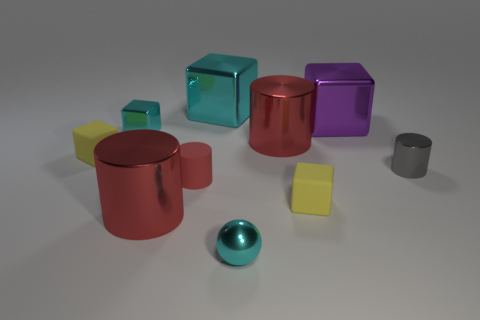What number of other things are there of the same color as the small sphere?
Give a very brief answer. 2. Do the metal sphere and the tiny shiny cylinder have the same color?
Your response must be concise. No. There is a yellow matte block to the left of the large metallic cylinder to the left of the small cyan shiny sphere; what size is it?
Your response must be concise. Small. Are the small cyan thing on the left side of the small red matte cylinder and the tiny yellow object that is on the right side of the tiny cyan block made of the same material?
Offer a terse response. No. There is a shiny cylinder on the right side of the purple block; is its color the same as the tiny metallic ball?
Offer a terse response. No. How many large metallic cylinders are on the left side of the cyan metal sphere?
Your answer should be compact. 1. Does the tiny gray object have the same material as the purple cube right of the small cyan metal cube?
Provide a short and direct response. Yes. What is the size of the sphere that is made of the same material as the small gray thing?
Offer a very short reply. Small. Are there more metallic things behind the tiny gray cylinder than cyan things in front of the purple block?
Give a very brief answer. Yes. Is there a big purple shiny thing that has the same shape as the big cyan object?
Keep it short and to the point. Yes. 